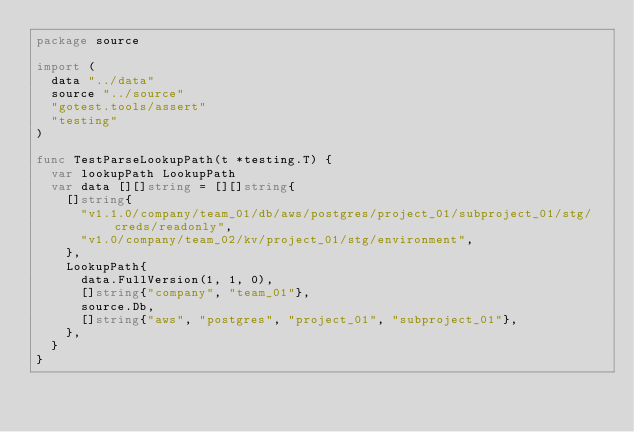<code> <loc_0><loc_0><loc_500><loc_500><_Go_>package source

import (
	data "../data"
	source "../source"
	"gotest.tools/assert"
	"testing"
)

func TestParseLookupPath(t *testing.T) {
	var lookupPath LookupPath
	var data [][]string = [][]string{
		[]string{
			"v1.1.0/company/team_01/db/aws/postgres/project_01/subproject_01/stg/creds/readonly",
			"v1.0/company/team_02/kv/project_01/stg/environment",
		},
		LookupPath{
			data.FullVersion(1, 1, 0),
			[]string{"company", "team_01"},
			source.Db,
			[]string{"aws", "postgres", "project_01", "subproject_01"},
		},
	}
}
</code> 